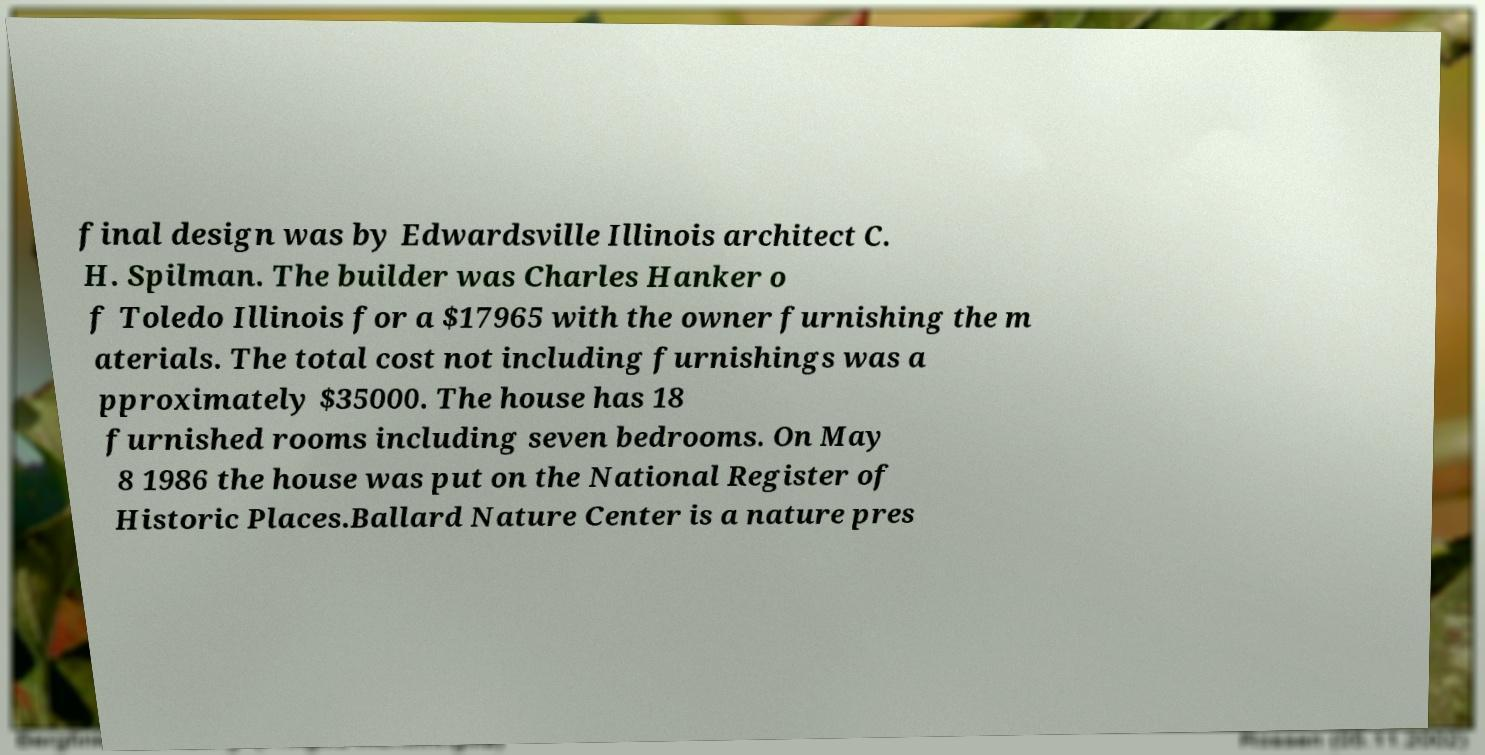What messages or text are displayed in this image? I need them in a readable, typed format. final design was by Edwardsville Illinois architect C. H. Spilman. The builder was Charles Hanker o f Toledo Illinois for a $17965 with the owner furnishing the m aterials. The total cost not including furnishings was a pproximately $35000. The house has 18 furnished rooms including seven bedrooms. On May 8 1986 the house was put on the National Register of Historic Places.Ballard Nature Center is a nature pres 